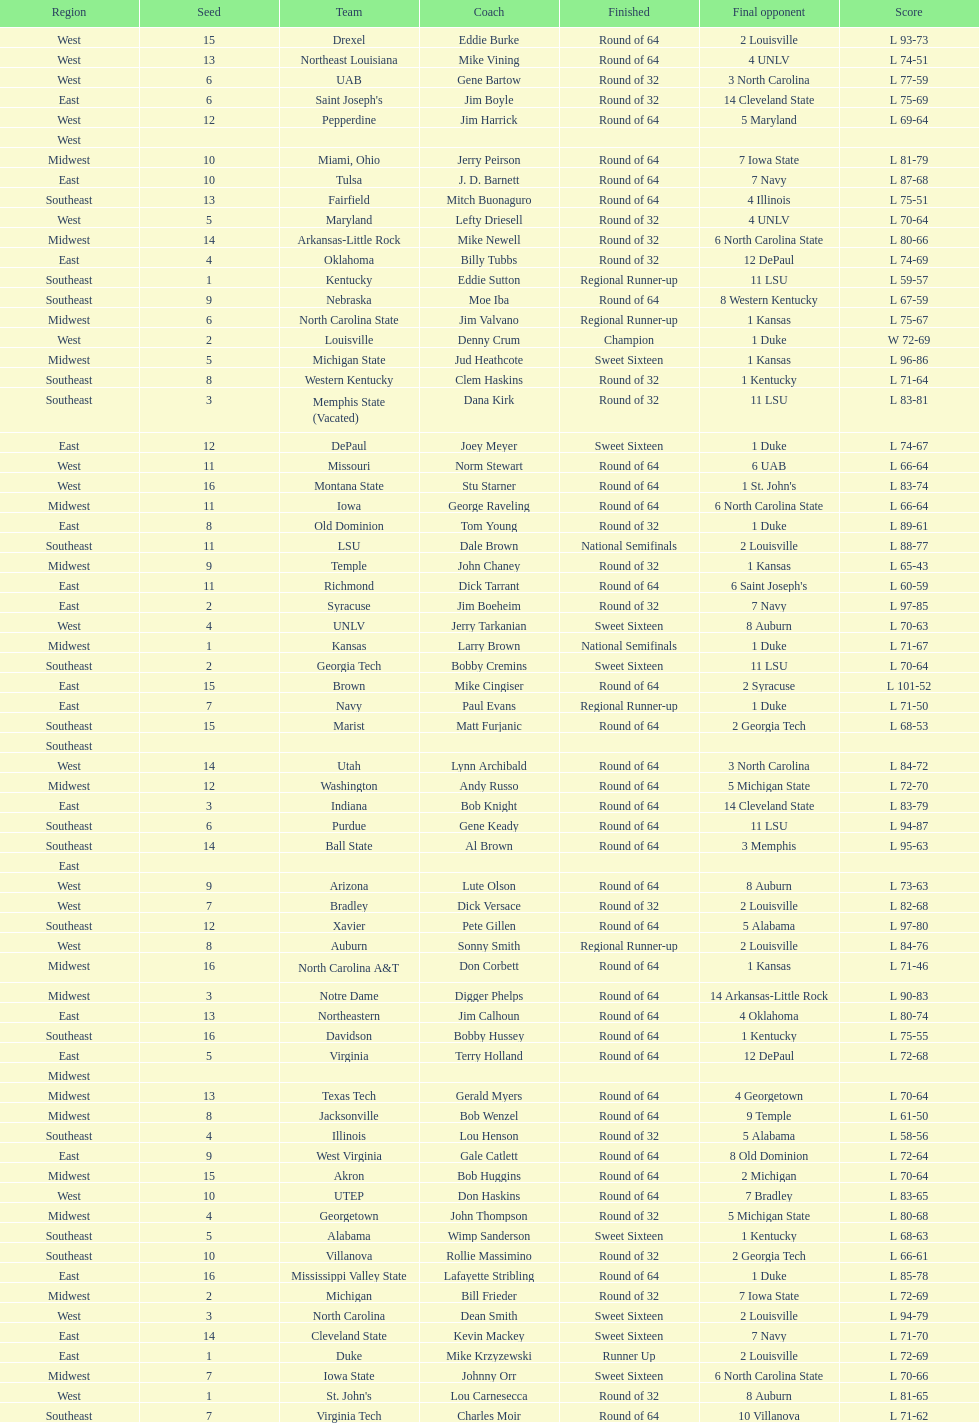Could you parse the entire table? {'header': ['Region', 'Seed', 'Team', 'Coach', 'Finished', 'Final opponent', 'Score'], 'rows': [['West', '15', 'Drexel', 'Eddie Burke', 'Round of 64', '2 Louisville', 'L 93-73'], ['West', '13', 'Northeast Louisiana', 'Mike Vining', 'Round of 64', '4 UNLV', 'L 74-51'], ['West', '6', 'UAB', 'Gene Bartow', 'Round of 32', '3 North Carolina', 'L 77-59'], ['East', '6', "Saint Joseph's", 'Jim Boyle', 'Round of 32', '14 Cleveland State', 'L 75-69'], ['West', '12', 'Pepperdine', 'Jim Harrick', 'Round of 64', '5 Maryland', 'L 69-64'], ['West', '', '', '', '', '', ''], ['Midwest', '10', 'Miami, Ohio', 'Jerry Peirson', 'Round of 64', '7 Iowa State', 'L 81-79'], ['East', '10', 'Tulsa', 'J. D. Barnett', 'Round of 64', '7 Navy', 'L 87-68'], ['Southeast', '13', 'Fairfield', 'Mitch Buonaguro', 'Round of 64', '4 Illinois', 'L 75-51'], ['West', '5', 'Maryland', 'Lefty Driesell', 'Round of 32', '4 UNLV', 'L 70-64'], ['Midwest', '14', 'Arkansas-Little Rock', 'Mike Newell', 'Round of 32', '6 North Carolina State', 'L 80-66'], ['East', '4', 'Oklahoma', 'Billy Tubbs', 'Round of 32', '12 DePaul', 'L 74-69'], ['Southeast', '1', 'Kentucky', 'Eddie Sutton', 'Regional Runner-up', '11 LSU', 'L 59-57'], ['Southeast', '9', 'Nebraska', 'Moe Iba', 'Round of 64', '8 Western Kentucky', 'L 67-59'], ['Midwest', '6', 'North Carolina State', 'Jim Valvano', 'Regional Runner-up', '1 Kansas', 'L 75-67'], ['West', '2', 'Louisville', 'Denny Crum', 'Champion', '1 Duke', 'W 72-69'], ['Midwest', '5', 'Michigan State', 'Jud Heathcote', 'Sweet Sixteen', '1 Kansas', 'L 96-86'], ['Southeast', '8', 'Western Kentucky', 'Clem Haskins', 'Round of 32', '1 Kentucky', 'L 71-64'], ['Southeast', '3', 'Memphis State (Vacated)', 'Dana Kirk', 'Round of 32', '11 LSU', 'L 83-81'], ['East', '12', 'DePaul', 'Joey Meyer', 'Sweet Sixteen', '1 Duke', 'L 74-67'], ['West', '11', 'Missouri', 'Norm Stewart', 'Round of 64', '6 UAB', 'L 66-64'], ['West', '16', 'Montana State', 'Stu Starner', 'Round of 64', "1 St. John's", 'L 83-74'], ['Midwest', '11', 'Iowa', 'George Raveling', 'Round of 64', '6 North Carolina State', 'L 66-64'], ['East', '8', 'Old Dominion', 'Tom Young', 'Round of 32', '1 Duke', 'L 89-61'], ['Southeast', '11', 'LSU', 'Dale Brown', 'National Semifinals', '2 Louisville', 'L 88-77'], ['Midwest', '9', 'Temple', 'John Chaney', 'Round of 32', '1 Kansas', 'L 65-43'], ['East', '11', 'Richmond', 'Dick Tarrant', 'Round of 64', "6 Saint Joseph's", 'L 60-59'], ['East', '2', 'Syracuse', 'Jim Boeheim', 'Round of 32', '7 Navy', 'L 97-85'], ['West', '4', 'UNLV', 'Jerry Tarkanian', 'Sweet Sixteen', '8 Auburn', 'L 70-63'], ['Midwest', '1', 'Kansas', 'Larry Brown', 'National Semifinals', '1 Duke', 'L 71-67'], ['Southeast', '2', 'Georgia Tech', 'Bobby Cremins', 'Sweet Sixteen', '11 LSU', 'L 70-64'], ['East', '15', 'Brown', 'Mike Cingiser', 'Round of 64', '2 Syracuse', 'L 101-52'], ['East', '7', 'Navy', 'Paul Evans', 'Regional Runner-up', '1 Duke', 'L 71-50'], ['Southeast', '15', 'Marist', 'Matt Furjanic', 'Round of 64', '2 Georgia Tech', 'L 68-53'], ['Southeast', '', '', '', '', '', ''], ['West', '14', 'Utah', 'Lynn Archibald', 'Round of 64', '3 North Carolina', 'L 84-72'], ['Midwest', '12', 'Washington', 'Andy Russo', 'Round of 64', '5 Michigan State', 'L 72-70'], ['East', '3', 'Indiana', 'Bob Knight', 'Round of 64', '14 Cleveland State', 'L 83-79'], ['Southeast', '6', 'Purdue', 'Gene Keady', 'Round of 64', '11 LSU', 'L 94-87'], ['Southeast', '14', 'Ball State', 'Al Brown', 'Round of 64', '3 Memphis', 'L 95-63'], ['East', '', '', '', '', '', ''], ['West', '9', 'Arizona', 'Lute Olson', 'Round of 64', '8 Auburn', 'L 73-63'], ['West', '7', 'Bradley', 'Dick Versace', 'Round of 32', '2 Louisville', 'L 82-68'], ['Southeast', '12', 'Xavier', 'Pete Gillen', 'Round of 64', '5 Alabama', 'L 97-80'], ['West', '8', 'Auburn', 'Sonny Smith', 'Regional Runner-up', '2 Louisville', 'L 84-76'], ['Midwest', '16', 'North Carolina A&T', 'Don Corbett', 'Round of 64', '1 Kansas', 'L 71-46'], ['Midwest', '3', 'Notre Dame', 'Digger Phelps', 'Round of 64', '14 Arkansas-Little Rock', 'L 90-83'], ['East', '13', 'Northeastern', 'Jim Calhoun', 'Round of 64', '4 Oklahoma', 'L 80-74'], ['Southeast', '16', 'Davidson', 'Bobby Hussey', 'Round of 64', '1 Kentucky', 'L 75-55'], ['East', '5', 'Virginia', 'Terry Holland', 'Round of 64', '12 DePaul', 'L 72-68'], ['Midwest', '', '', '', '', '', ''], ['Midwest', '13', 'Texas Tech', 'Gerald Myers', 'Round of 64', '4 Georgetown', 'L 70-64'], ['Midwest', '8', 'Jacksonville', 'Bob Wenzel', 'Round of 64', '9 Temple', 'L 61-50'], ['Southeast', '4', 'Illinois', 'Lou Henson', 'Round of 32', '5 Alabama', 'L 58-56'], ['East', '9', 'West Virginia', 'Gale Catlett', 'Round of 64', '8 Old Dominion', 'L 72-64'], ['Midwest', '15', 'Akron', 'Bob Huggins', 'Round of 64', '2 Michigan', 'L 70-64'], ['West', '10', 'UTEP', 'Don Haskins', 'Round of 64', '7 Bradley', 'L 83-65'], ['Midwest', '4', 'Georgetown', 'John Thompson', 'Round of 32', '5 Michigan State', 'L 80-68'], ['Southeast', '5', 'Alabama', 'Wimp Sanderson', 'Sweet Sixteen', '1 Kentucky', 'L 68-63'], ['Southeast', '10', 'Villanova', 'Rollie Massimino', 'Round of 32', '2 Georgia Tech', 'L 66-61'], ['East', '16', 'Mississippi Valley State', 'Lafayette Stribling', 'Round of 64', '1 Duke', 'L 85-78'], ['Midwest', '2', 'Michigan', 'Bill Frieder', 'Round of 32', '7 Iowa State', 'L 72-69'], ['West', '3', 'North Carolina', 'Dean Smith', 'Sweet Sixteen', '2 Louisville', 'L 94-79'], ['East', '14', 'Cleveland State', 'Kevin Mackey', 'Sweet Sixteen', '7 Navy', 'L 71-70'], ['East', '1', 'Duke', 'Mike Krzyzewski', 'Runner Up', '2 Louisville', 'L 72-69'], ['Midwest', '7', 'Iowa State', 'Johnny Orr', 'Sweet Sixteen', '6 North Carolina State', 'L 70-66'], ['West', '1', "St. John's", 'Lou Carnesecca', 'Round of 32', '8 Auburn', 'L 81-65'], ['Southeast', '7', 'Virginia Tech', 'Charles Moir', 'Round of 64', '10 Villanova', 'L 71-62']]} How many teams are present in the east region? 16. 